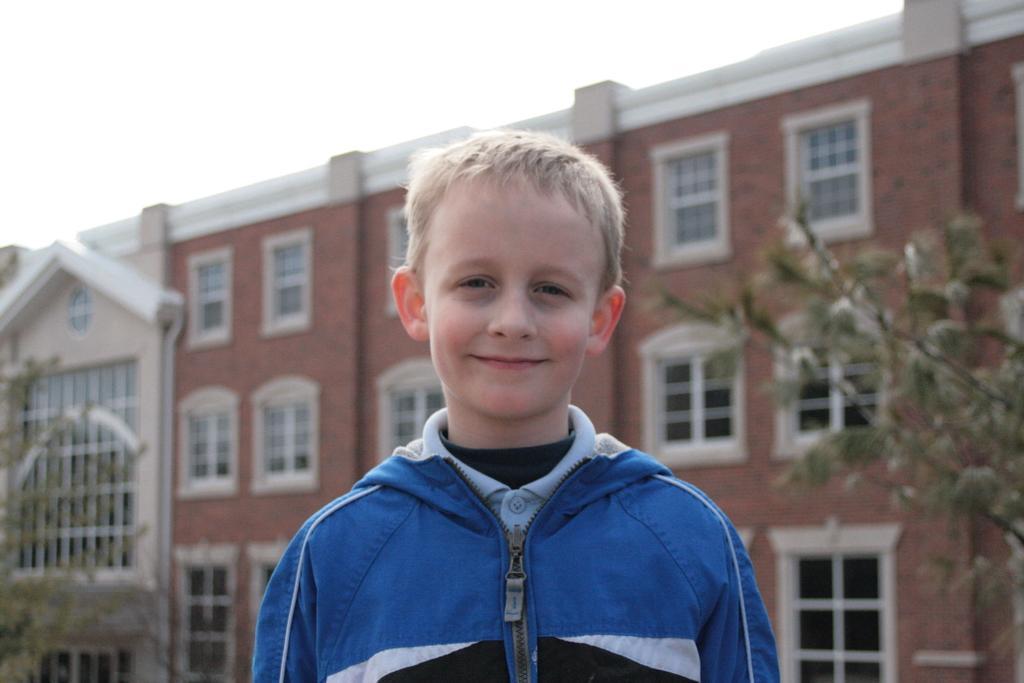How would you summarize this image in a sentence or two? In this image I can see a boy is smiling, he wore blue color coat, behind him there is a big building, there are trees on either side of this image, at the top it is the sky. 